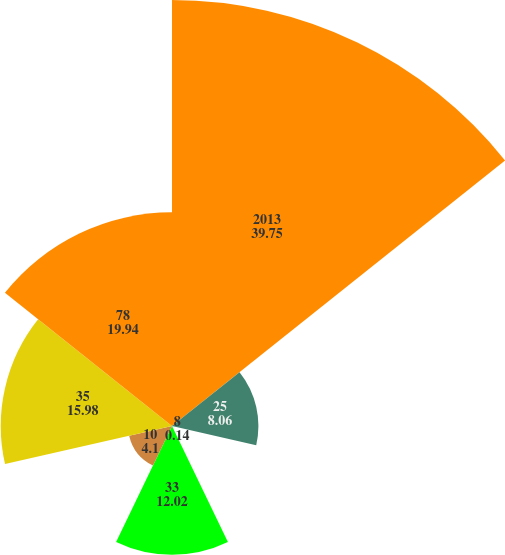Convert chart. <chart><loc_0><loc_0><loc_500><loc_500><pie_chart><fcel>2013<fcel>25<fcel>8<fcel>33<fcel>10<fcel>35<fcel>78<nl><fcel>39.75%<fcel>8.06%<fcel>0.14%<fcel>12.02%<fcel>4.1%<fcel>15.98%<fcel>19.94%<nl></chart> 